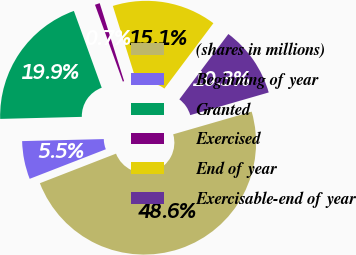<chart> <loc_0><loc_0><loc_500><loc_500><pie_chart><fcel>(shares in millions)<fcel>Beginning of year<fcel>Granted<fcel>Exercised<fcel>End of year<fcel>Exercisable-end of year<nl><fcel>48.58%<fcel>5.5%<fcel>19.86%<fcel>0.71%<fcel>15.07%<fcel>10.28%<nl></chart> 